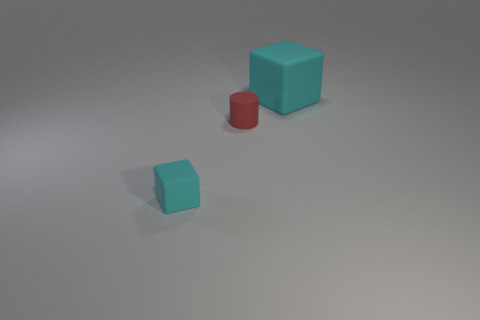Are there any other things of the same color as the tiny cylinder?
Keep it short and to the point. No. There is a small matte cylinder; how many rubber blocks are behind it?
Make the answer very short. 1. What number of other cyan objects have the same shape as the large object?
Offer a very short reply. 1. How many tiny objects are cyan things or brown blocks?
Offer a terse response. 1. There is a cube in front of the big cyan object; is its color the same as the big rubber cube?
Offer a terse response. Yes. Does the rubber cube behind the tiny cyan rubber object have the same color as the small cylinder that is left of the large cyan cube?
Keep it short and to the point. No. Are there any other things made of the same material as the big object?
Ensure brevity in your answer.  Yes. What number of red things are either tiny rubber blocks or small matte things?
Offer a very short reply. 1. Is the number of cyan matte objects to the left of the red rubber object greater than the number of tiny purple metallic cubes?
Keep it short and to the point. Yes. The tiny cylinder that is made of the same material as the small cyan block is what color?
Your answer should be compact. Red. 